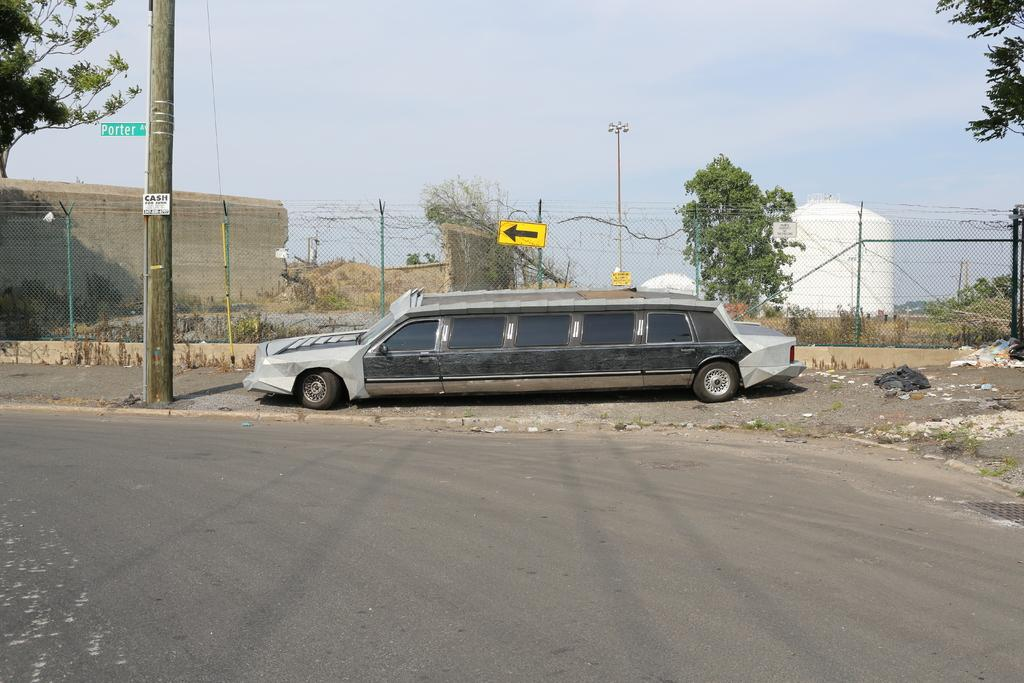What can be seen parked beside the road in the image? There is a car parked aside of the road in the image. What other object is present in the image besides the car? There is a sign board in the image. What might provide illumination at night in the image? There is a street light in the image. What type of vegetation is visible in the image? There are trees in the image. How many rods can be seen in the image? There are no rods present in the image. What type of land is visible in the image? The image does not show any specific type of land; it only shows a car parked beside the road, a sign board, a street light, and trees. 